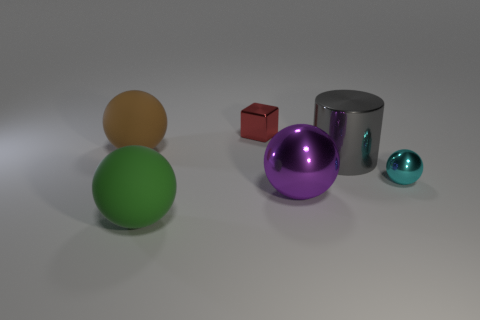Are the tiny cyan object in front of the brown thing and the big sphere in front of the purple thing made of the same material?
Your answer should be compact. No. How many big green things have the same shape as the cyan object?
Keep it short and to the point. 1. What number of things are either purple rubber spheres or shiny objects in front of the cylinder?
Provide a short and direct response. 2. What is the small red thing made of?
Your response must be concise. Metal. What material is the tiny cyan object that is the same shape as the large purple metal thing?
Your response must be concise. Metal. There is a small metal object in front of the small object behind the large gray cylinder; what is its color?
Provide a short and direct response. Cyan. What number of metal things are large brown things or balls?
Your answer should be very brief. 2. Are the tiny block and the large cylinder made of the same material?
Your response must be concise. Yes. What is the small object that is right of the shiny ball in front of the tiny metal sphere made of?
Offer a terse response. Metal. How many small things are cyan things or cubes?
Offer a very short reply. 2. 